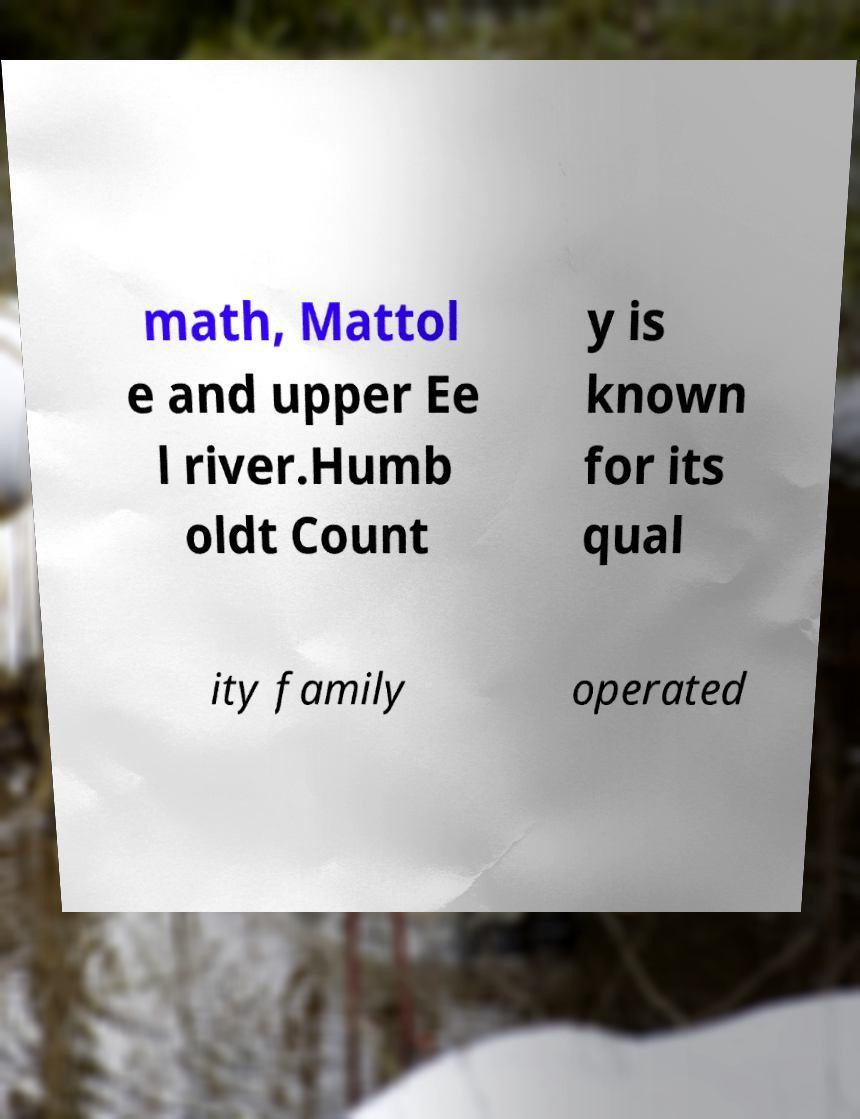What messages or text are displayed in this image? I need them in a readable, typed format. math, Mattol e and upper Ee l river.Humb oldt Count y is known for its qual ity family operated 